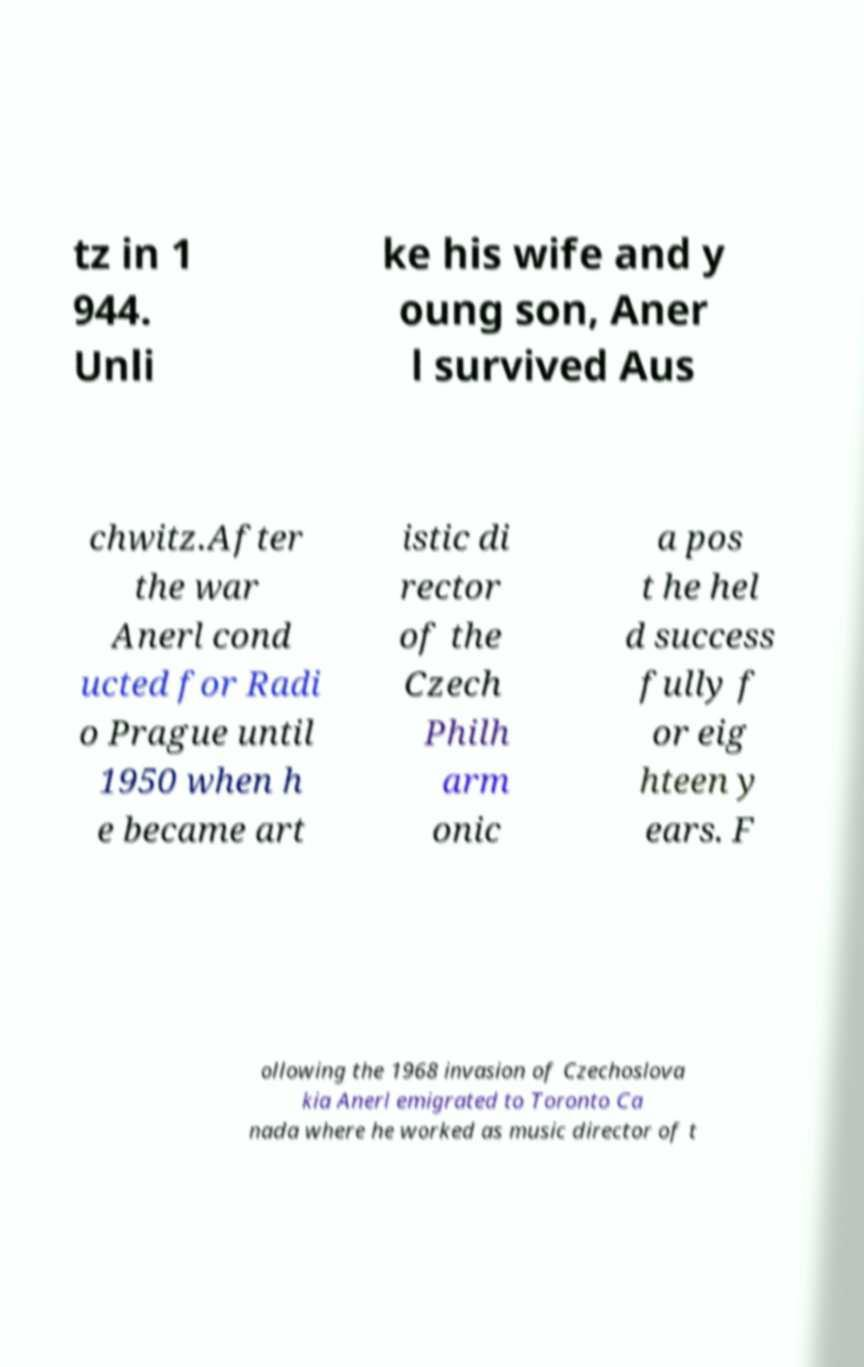Please identify and transcribe the text found in this image. tz in 1 944. Unli ke his wife and y oung son, Aner l survived Aus chwitz.After the war Anerl cond ucted for Radi o Prague until 1950 when h e became art istic di rector of the Czech Philh arm onic a pos t he hel d success fully f or eig hteen y ears. F ollowing the 1968 invasion of Czechoslova kia Anerl emigrated to Toronto Ca nada where he worked as music director of t 